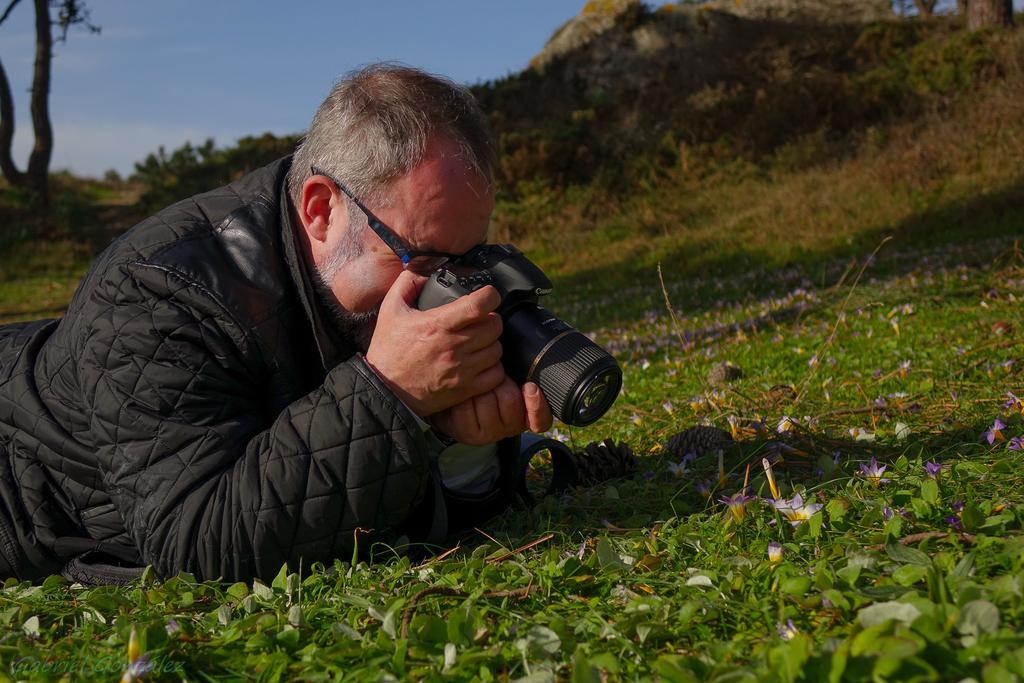How would you summarize this image in a sentence or two? This person is lying on a grass. He wore jacket, spectacles and holding a camera. Far there are number of plants and trees. 